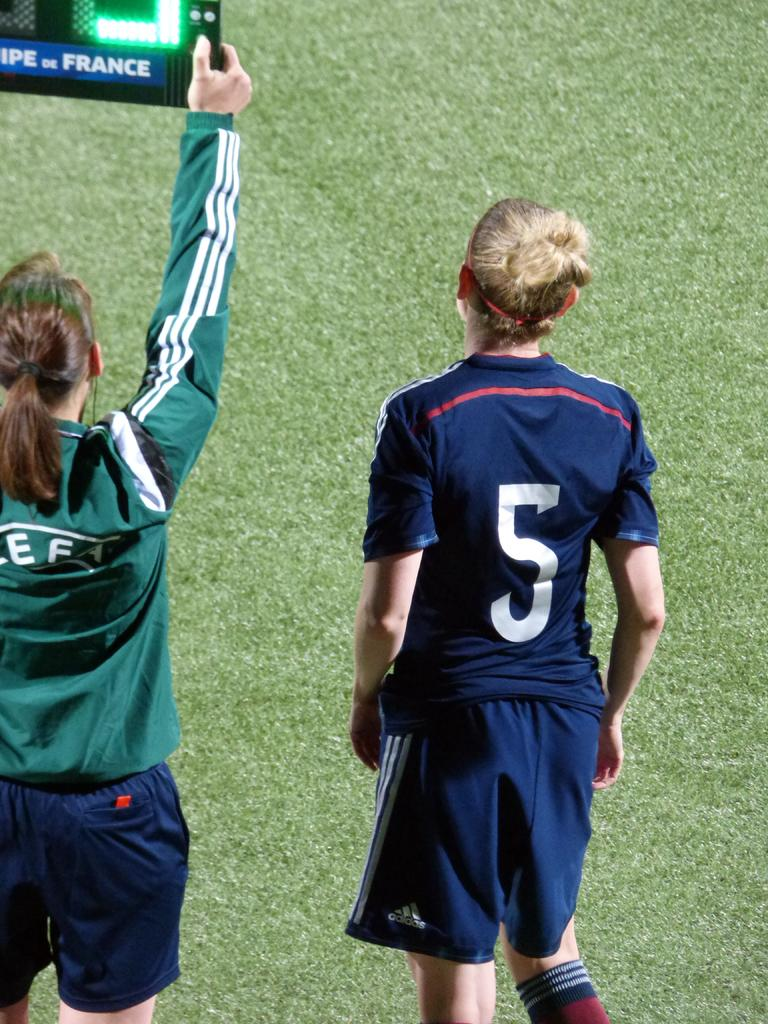<image>
Share a concise interpretation of the image provided. Some women playing sport, one with a number five on her shirt. 